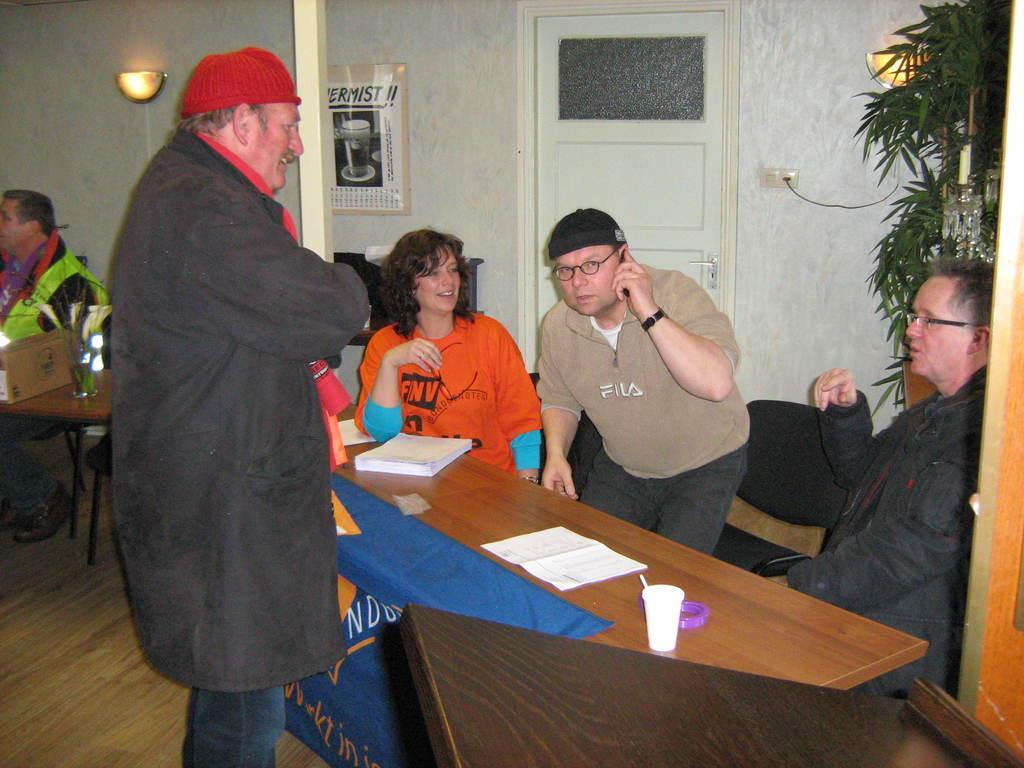Describe this image in one or two sentences. Here is a person standing wearing a red cap and jerkin. There are group of people sitting on the chairs. This is a table. On this table I can see a tumbler,paper,book placed on it. This is a blue cloth hanging through the table. At background I can see a wall lamp attached to the wall. This is a door with a door handle. At the right corner of the image I can see a Tree. At the left corner of the image I can see a man sitting on the chair. 